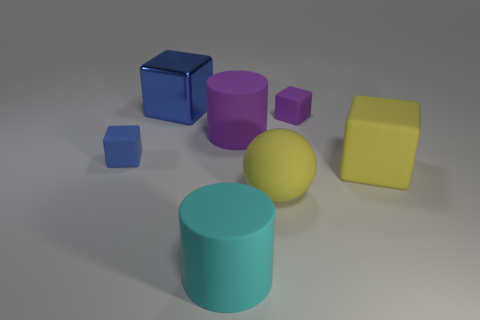Subtract 1 blocks. How many blocks are left? 3 Subtract all red cubes. Subtract all purple cylinders. How many cubes are left? 4 Add 1 big cyan rubber cylinders. How many objects exist? 8 Subtract all cylinders. How many objects are left? 5 Subtract 0 blue cylinders. How many objects are left? 7 Subtract all small blue cylinders. Subtract all large yellow matte objects. How many objects are left? 5 Add 3 purple cylinders. How many purple cylinders are left? 4 Add 5 large red matte cylinders. How many large red matte cylinders exist? 5 